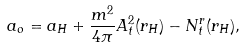<formula> <loc_0><loc_0><loc_500><loc_500>a _ { o } = a _ { H } + \frac { m ^ { 2 } } { 4 \pi } A _ { t } ^ { 2 } ( r _ { H } ) - N ^ { r } _ { t } ( r _ { H } ) ,</formula> 